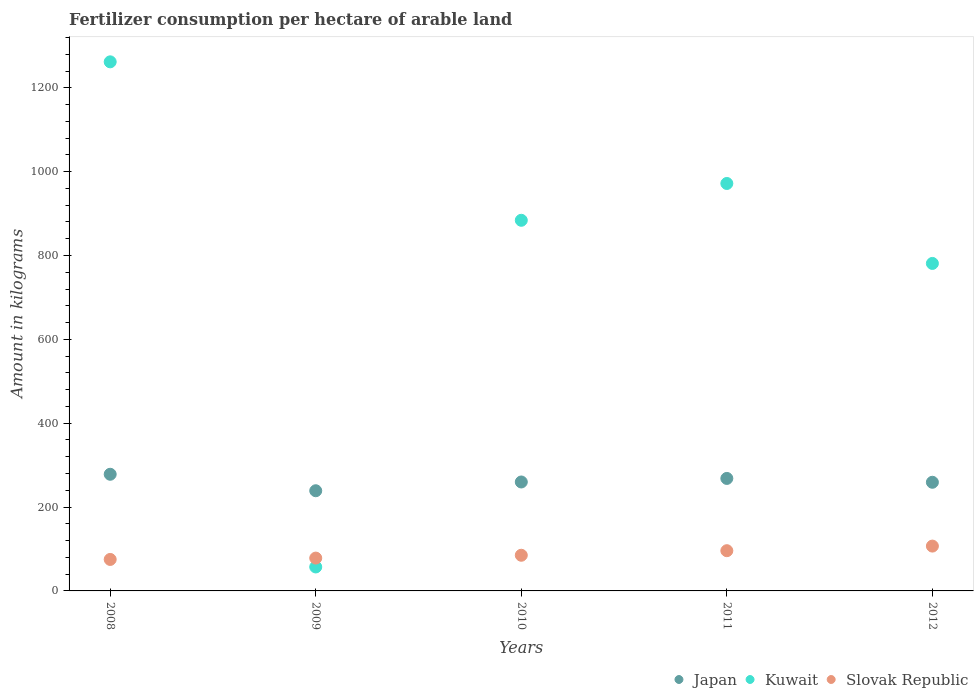How many different coloured dotlines are there?
Ensure brevity in your answer.  3. Is the number of dotlines equal to the number of legend labels?
Provide a short and direct response. Yes. What is the amount of fertilizer consumption in Slovak Republic in 2010?
Give a very brief answer. 85.06. Across all years, what is the maximum amount of fertilizer consumption in Kuwait?
Make the answer very short. 1261.95. Across all years, what is the minimum amount of fertilizer consumption in Slovak Republic?
Keep it short and to the point. 75.08. In which year was the amount of fertilizer consumption in Kuwait maximum?
Your answer should be compact. 2008. In which year was the amount of fertilizer consumption in Kuwait minimum?
Provide a short and direct response. 2009. What is the total amount of fertilizer consumption in Japan in the graph?
Provide a short and direct response. 1304.45. What is the difference between the amount of fertilizer consumption in Kuwait in 2009 and that in 2012?
Ensure brevity in your answer.  -723.96. What is the difference between the amount of fertilizer consumption in Kuwait in 2010 and the amount of fertilizer consumption in Japan in 2009?
Your answer should be very brief. 645.07. What is the average amount of fertilizer consumption in Kuwait per year?
Offer a terse response. 791.2. In the year 2008, what is the difference between the amount of fertilizer consumption in Kuwait and amount of fertilizer consumption in Slovak Republic?
Your answer should be very brief. 1186.86. In how many years, is the amount of fertilizer consumption in Slovak Republic greater than 360 kg?
Offer a very short reply. 0. What is the ratio of the amount of fertilizer consumption in Japan in 2009 to that in 2012?
Your response must be concise. 0.92. Is the difference between the amount of fertilizer consumption in Kuwait in 2008 and 2011 greater than the difference between the amount of fertilizer consumption in Slovak Republic in 2008 and 2011?
Provide a succinct answer. Yes. What is the difference between the highest and the second highest amount of fertilizer consumption in Slovak Republic?
Ensure brevity in your answer.  10.98. What is the difference between the highest and the lowest amount of fertilizer consumption in Kuwait?
Provide a succinct answer. 1204.8. In how many years, is the amount of fertilizer consumption in Japan greater than the average amount of fertilizer consumption in Japan taken over all years?
Make the answer very short. 2. Is it the case that in every year, the sum of the amount of fertilizer consumption in Slovak Republic and amount of fertilizer consumption in Japan  is greater than the amount of fertilizer consumption in Kuwait?
Your answer should be very brief. No. Does the amount of fertilizer consumption in Japan monotonically increase over the years?
Your answer should be very brief. No. Is the amount of fertilizer consumption in Slovak Republic strictly greater than the amount of fertilizer consumption in Japan over the years?
Provide a short and direct response. No. How many dotlines are there?
Provide a short and direct response. 3. How many years are there in the graph?
Your answer should be very brief. 5. What is the difference between two consecutive major ticks on the Y-axis?
Provide a short and direct response. 200. How many legend labels are there?
Your response must be concise. 3. What is the title of the graph?
Offer a very short reply. Fertilizer consumption per hectare of arable land. Does "Israel" appear as one of the legend labels in the graph?
Offer a terse response. No. What is the label or title of the Y-axis?
Offer a very short reply. Amount in kilograms. What is the Amount in kilograms of Japan in 2008?
Ensure brevity in your answer.  278.23. What is the Amount in kilograms in Kuwait in 2008?
Give a very brief answer. 1261.95. What is the Amount in kilograms of Slovak Republic in 2008?
Offer a terse response. 75.08. What is the Amount in kilograms in Japan in 2009?
Provide a short and direct response. 238.93. What is the Amount in kilograms of Kuwait in 2009?
Your answer should be compact. 57.14. What is the Amount in kilograms in Slovak Republic in 2009?
Offer a terse response. 78.31. What is the Amount in kilograms of Japan in 2010?
Offer a very short reply. 259.83. What is the Amount in kilograms of Kuwait in 2010?
Make the answer very short. 884. What is the Amount in kilograms of Slovak Republic in 2010?
Give a very brief answer. 85.06. What is the Amount in kilograms of Japan in 2011?
Your response must be concise. 268.31. What is the Amount in kilograms of Kuwait in 2011?
Offer a terse response. 971.81. What is the Amount in kilograms of Slovak Republic in 2011?
Provide a short and direct response. 95.94. What is the Amount in kilograms of Japan in 2012?
Provide a succinct answer. 259.15. What is the Amount in kilograms in Kuwait in 2012?
Ensure brevity in your answer.  781.1. What is the Amount in kilograms in Slovak Republic in 2012?
Your answer should be compact. 106.92. Across all years, what is the maximum Amount in kilograms of Japan?
Your answer should be very brief. 278.23. Across all years, what is the maximum Amount in kilograms of Kuwait?
Make the answer very short. 1261.95. Across all years, what is the maximum Amount in kilograms of Slovak Republic?
Keep it short and to the point. 106.92. Across all years, what is the minimum Amount in kilograms in Japan?
Offer a very short reply. 238.93. Across all years, what is the minimum Amount in kilograms in Kuwait?
Provide a short and direct response. 57.14. Across all years, what is the minimum Amount in kilograms in Slovak Republic?
Your response must be concise. 75.08. What is the total Amount in kilograms of Japan in the graph?
Give a very brief answer. 1304.45. What is the total Amount in kilograms of Kuwait in the graph?
Offer a terse response. 3956. What is the total Amount in kilograms in Slovak Republic in the graph?
Keep it short and to the point. 441.31. What is the difference between the Amount in kilograms of Japan in 2008 and that in 2009?
Make the answer very short. 39.3. What is the difference between the Amount in kilograms of Kuwait in 2008 and that in 2009?
Provide a short and direct response. 1204.8. What is the difference between the Amount in kilograms of Slovak Republic in 2008 and that in 2009?
Keep it short and to the point. -3.23. What is the difference between the Amount in kilograms in Japan in 2008 and that in 2010?
Your answer should be very brief. 18.39. What is the difference between the Amount in kilograms of Kuwait in 2008 and that in 2010?
Keep it short and to the point. 377.95. What is the difference between the Amount in kilograms of Slovak Republic in 2008 and that in 2010?
Give a very brief answer. -9.98. What is the difference between the Amount in kilograms in Japan in 2008 and that in 2011?
Make the answer very short. 9.92. What is the difference between the Amount in kilograms in Kuwait in 2008 and that in 2011?
Provide a succinct answer. 290.14. What is the difference between the Amount in kilograms in Slovak Republic in 2008 and that in 2011?
Offer a very short reply. -20.85. What is the difference between the Amount in kilograms of Japan in 2008 and that in 2012?
Make the answer very short. 19.08. What is the difference between the Amount in kilograms of Kuwait in 2008 and that in 2012?
Give a very brief answer. 480.85. What is the difference between the Amount in kilograms in Slovak Republic in 2008 and that in 2012?
Give a very brief answer. -31.84. What is the difference between the Amount in kilograms in Japan in 2009 and that in 2010?
Your answer should be very brief. -20.91. What is the difference between the Amount in kilograms of Kuwait in 2009 and that in 2010?
Your answer should be compact. -826.86. What is the difference between the Amount in kilograms in Slovak Republic in 2009 and that in 2010?
Provide a short and direct response. -6.75. What is the difference between the Amount in kilograms of Japan in 2009 and that in 2011?
Provide a succinct answer. -29.38. What is the difference between the Amount in kilograms in Kuwait in 2009 and that in 2011?
Give a very brief answer. -914.67. What is the difference between the Amount in kilograms of Slovak Republic in 2009 and that in 2011?
Offer a terse response. -17.63. What is the difference between the Amount in kilograms in Japan in 2009 and that in 2012?
Make the answer very short. -20.22. What is the difference between the Amount in kilograms in Kuwait in 2009 and that in 2012?
Provide a succinct answer. -723.96. What is the difference between the Amount in kilograms of Slovak Republic in 2009 and that in 2012?
Provide a succinct answer. -28.61. What is the difference between the Amount in kilograms in Japan in 2010 and that in 2011?
Offer a very short reply. -8.47. What is the difference between the Amount in kilograms of Kuwait in 2010 and that in 2011?
Give a very brief answer. -87.81. What is the difference between the Amount in kilograms in Slovak Republic in 2010 and that in 2011?
Give a very brief answer. -10.87. What is the difference between the Amount in kilograms in Japan in 2010 and that in 2012?
Your response must be concise. 0.69. What is the difference between the Amount in kilograms of Kuwait in 2010 and that in 2012?
Offer a terse response. 102.9. What is the difference between the Amount in kilograms of Slovak Republic in 2010 and that in 2012?
Ensure brevity in your answer.  -21.86. What is the difference between the Amount in kilograms in Japan in 2011 and that in 2012?
Your answer should be compact. 9.16. What is the difference between the Amount in kilograms in Kuwait in 2011 and that in 2012?
Offer a very short reply. 190.71. What is the difference between the Amount in kilograms in Slovak Republic in 2011 and that in 2012?
Give a very brief answer. -10.98. What is the difference between the Amount in kilograms of Japan in 2008 and the Amount in kilograms of Kuwait in 2009?
Offer a very short reply. 221.09. What is the difference between the Amount in kilograms in Japan in 2008 and the Amount in kilograms in Slovak Republic in 2009?
Provide a short and direct response. 199.92. What is the difference between the Amount in kilograms of Kuwait in 2008 and the Amount in kilograms of Slovak Republic in 2009?
Your response must be concise. 1183.64. What is the difference between the Amount in kilograms in Japan in 2008 and the Amount in kilograms in Kuwait in 2010?
Keep it short and to the point. -605.77. What is the difference between the Amount in kilograms of Japan in 2008 and the Amount in kilograms of Slovak Republic in 2010?
Your response must be concise. 193.16. What is the difference between the Amount in kilograms in Kuwait in 2008 and the Amount in kilograms in Slovak Republic in 2010?
Provide a succinct answer. 1176.88. What is the difference between the Amount in kilograms in Japan in 2008 and the Amount in kilograms in Kuwait in 2011?
Make the answer very short. -693.58. What is the difference between the Amount in kilograms in Japan in 2008 and the Amount in kilograms in Slovak Republic in 2011?
Your response must be concise. 182.29. What is the difference between the Amount in kilograms of Kuwait in 2008 and the Amount in kilograms of Slovak Republic in 2011?
Your response must be concise. 1166.01. What is the difference between the Amount in kilograms in Japan in 2008 and the Amount in kilograms in Kuwait in 2012?
Provide a succinct answer. -502.87. What is the difference between the Amount in kilograms of Japan in 2008 and the Amount in kilograms of Slovak Republic in 2012?
Your answer should be compact. 171.31. What is the difference between the Amount in kilograms of Kuwait in 2008 and the Amount in kilograms of Slovak Republic in 2012?
Give a very brief answer. 1155.03. What is the difference between the Amount in kilograms in Japan in 2009 and the Amount in kilograms in Kuwait in 2010?
Make the answer very short. -645.07. What is the difference between the Amount in kilograms of Japan in 2009 and the Amount in kilograms of Slovak Republic in 2010?
Provide a short and direct response. 153.86. What is the difference between the Amount in kilograms in Kuwait in 2009 and the Amount in kilograms in Slovak Republic in 2010?
Keep it short and to the point. -27.92. What is the difference between the Amount in kilograms in Japan in 2009 and the Amount in kilograms in Kuwait in 2011?
Keep it short and to the point. -732.88. What is the difference between the Amount in kilograms of Japan in 2009 and the Amount in kilograms of Slovak Republic in 2011?
Offer a very short reply. 142.99. What is the difference between the Amount in kilograms in Kuwait in 2009 and the Amount in kilograms in Slovak Republic in 2011?
Ensure brevity in your answer.  -38.79. What is the difference between the Amount in kilograms of Japan in 2009 and the Amount in kilograms of Kuwait in 2012?
Ensure brevity in your answer.  -542.17. What is the difference between the Amount in kilograms in Japan in 2009 and the Amount in kilograms in Slovak Republic in 2012?
Keep it short and to the point. 132.01. What is the difference between the Amount in kilograms of Kuwait in 2009 and the Amount in kilograms of Slovak Republic in 2012?
Make the answer very short. -49.78. What is the difference between the Amount in kilograms of Japan in 2010 and the Amount in kilograms of Kuwait in 2011?
Provide a short and direct response. -711.98. What is the difference between the Amount in kilograms in Japan in 2010 and the Amount in kilograms in Slovak Republic in 2011?
Ensure brevity in your answer.  163.9. What is the difference between the Amount in kilograms of Kuwait in 2010 and the Amount in kilograms of Slovak Republic in 2011?
Offer a very short reply. 788.06. What is the difference between the Amount in kilograms in Japan in 2010 and the Amount in kilograms in Kuwait in 2012?
Your answer should be very brief. -521.27. What is the difference between the Amount in kilograms of Japan in 2010 and the Amount in kilograms of Slovak Republic in 2012?
Offer a very short reply. 152.91. What is the difference between the Amount in kilograms of Kuwait in 2010 and the Amount in kilograms of Slovak Republic in 2012?
Keep it short and to the point. 777.08. What is the difference between the Amount in kilograms of Japan in 2011 and the Amount in kilograms of Kuwait in 2012?
Make the answer very short. -512.79. What is the difference between the Amount in kilograms of Japan in 2011 and the Amount in kilograms of Slovak Republic in 2012?
Make the answer very short. 161.39. What is the difference between the Amount in kilograms of Kuwait in 2011 and the Amount in kilograms of Slovak Republic in 2012?
Your answer should be compact. 864.89. What is the average Amount in kilograms of Japan per year?
Make the answer very short. 260.89. What is the average Amount in kilograms in Kuwait per year?
Ensure brevity in your answer.  791.2. What is the average Amount in kilograms in Slovak Republic per year?
Make the answer very short. 88.26. In the year 2008, what is the difference between the Amount in kilograms in Japan and Amount in kilograms in Kuwait?
Provide a short and direct response. -983.72. In the year 2008, what is the difference between the Amount in kilograms of Japan and Amount in kilograms of Slovak Republic?
Offer a terse response. 203.14. In the year 2008, what is the difference between the Amount in kilograms of Kuwait and Amount in kilograms of Slovak Republic?
Your answer should be compact. 1186.86. In the year 2009, what is the difference between the Amount in kilograms in Japan and Amount in kilograms in Kuwait?
Give a very brief answer. 181.79. In the year 2009, what is the difference between the Amount in kilograms of Japan and Amount in kilograms of Slovak Republic?
Your answer should be compact. 160.62. In the year 2009, what is the difference between the Amount in kilograms in Kuwait and Amount in kilograms in Slovak Republic?
Your answer should be compact. -21.17. In the year 2010, what is the difference between the Amount in kilograms of Japan and Amount in kilograms of Kuwait?
Your answer should be compact. -624.17. In the year 2010, what is the difference between the Amount in kilograms in Japan and Amount in kilograms in Slovak Republic?
Provide a succinct answer. 174.77. In the year 2010, what is the difference between the Amount in kilograms of Kuwait and Amount in kilograms of Slovak Republic?
Provide a succinct answer. 798.94. In the year 2011, what is the difference between the Amount in kilograms in Japan and Amount in kilograms in Kuwait?
Keep it short and to the point. -703.5. In the year 2011, what is the difference between the Amount in kilograms of Japan and Amount in kilograms of Slovak Republic?
Make the answer very short. 172.37. In the year 2011, what is the difference between the Amount in kilograms in Kuwait and Amount in kilograms in Slovak Republic?
Make the answer very short. 875.87. In the year 2012, what is the difference between the Amount in kilograms in Japan and Amount in kilograms in Kuwait?
Offer a terse response. -521.95. In the year 2012, what is the difference between the Amount in kilograms of Japan and Amount in kilograms of Slovak Republic?
Give a very brief answer. 152.23. In the year 2012, what is the difference between the Amount in kilograms of Kuwait and Amount in kilograms of Slovak Republic?
Ensure brevity in your answer.  674.18. What is the ratio of the Amount in kilograms in Japan in 2008 to that in 2009?
Keep it short and to the point. 1.16. What is the ratio of the Amount in kilograms in Kuwait in 2008 to that in 2009?
Offer a very short reply. 22.08. What is the ratio of the Amount in kilograms in Slovak Republic in 2008 to that in 2009?
Make the answer very short. 0.96. What is the ratio of the Amount in kilograms in Japan in 2008 to that in 2010?
Keep it short and to the point. 1.07. What is the ratio of the Amount in kilograms of Kuwait in 2008 to that in 2010?
Keep it short and to the point. 1.43. What is the ratio of the Amount in kilograms of Slovak Republic in 2008 to that in 2010?
Your answer should be very brief. 0.88. What is the ratio of the Amount in kilograms in Kuwait in 2008 to that in 2011?
Your answer should be very brief. 1.3. What is the ratio of the Amount in kilograms in Slovak Republic in 2008 to that in 2011?
Offer a very short reply. 0.78. What is the ratio of the Amount in kilograms of Japan in 2008 to that in 2012?
Give a very brief answer. 1.07. What is the ratio of the Amount in kilograms of Kuwait in 2008 to that in 2012?
Ensure brevity in your answer.  1.62. What is the ratio of the Amount in kilograms of Slovak Republic in 2008 to that in 2012?
Give a very brief answer. 0.7. What is the ratio of the Amount in kilograms in Japan in 2009 to that in 2010?
Your answer should be very brief. 0.92. What is the ratio of the Amount in kilograms of Kuwait in 2009 to that in 2010?
Offer a terse response. 0.06. What is the ratio of the Amount in kilograms in Slovak Republic in 2009 to that in 2010?
Provide a short and direct response. 0.92. What is the ratio of the Amount in kilograms in Japan in 2009 to that in 2011?
Make the answer very short. 0.89. What is the ratio of the Amount in kilograms of Kuwait in 2009 to that in 2011?
Your response must be concise. 0.06. What is the ratio of the Amount in kilograms of Slovak Republic in 2009 to that in 2011?
Give a very brief answer. 0.82. What is the ratio of the Amount in kilograms in Japan in 2009 to that in 2012?
Offer a terse response. 0.92. What is the ratio of the Amount in kilograms of Kuwait in 2009 to that in 2012?
Provide a succinct answer. 0.07. What is the ratio of the Amount in kilograms in Slovak Republic in 2009 to that in 2012?
Provide a short and direct response. 0.73. What is the ratio of the Amount in kilograms of Japan in 2010 to that in 2011?
Give a very brief answer. 0.97. What is the ratio of the Amount in kilograms of Kuwait in 2010 to that in 2011?
Your answer should be very brief. 0.91. What is the ratio of the Amount in kilograms in Slovak Republic in 2010 to that in 2011?
Your response must be concise. 0.89. What is the ratio of the Amount in kilograms of Kuwait in 2010 to that in 2012?
Provide a succinct answer. 1.13. What is the ratio of the Amount in kilograms of Slovak Republic in 2010 to that in 2012?
Your response must be concise. 0.8. What is the ratio of the Amount in kilograms in Japan in 2011 to that in 2012?
Offer a very short reply. 1.04. What is the ratio of the Amount in kilograms of Kuwait in 2011 to that in 2012?
Provide a short and direct response. 1.24. What is the ratio of the Amount in kilograms of Slovak Republic in 2011 to that in 2012?
Offer a terse response. 0.9. What is the difference between the highest and the second highest Amount in kilograms of Japan?
Keep it short and to the point. 9.92. What is the difference between the highest and the second highest Amount in kilograms of Kuwait?
Give a very brief answer. 290.14. What is the difference between the highest and the second highest Amount in kilograms in Slovak Republic?
Provide a succinct answer. 10.98. What is the difference between the highest and the lowest Amount in kilograms of Japan?
Offer a terse response. 39.3. What is the difference between the highest and the lowest Amount in kilograms in Kuwait?
Provide a short and direct response. 1204.8. What is the difference between the highest and the lowest Amount in kilograms of Slovak Republic?
Your answer should be compact. 31.84. 